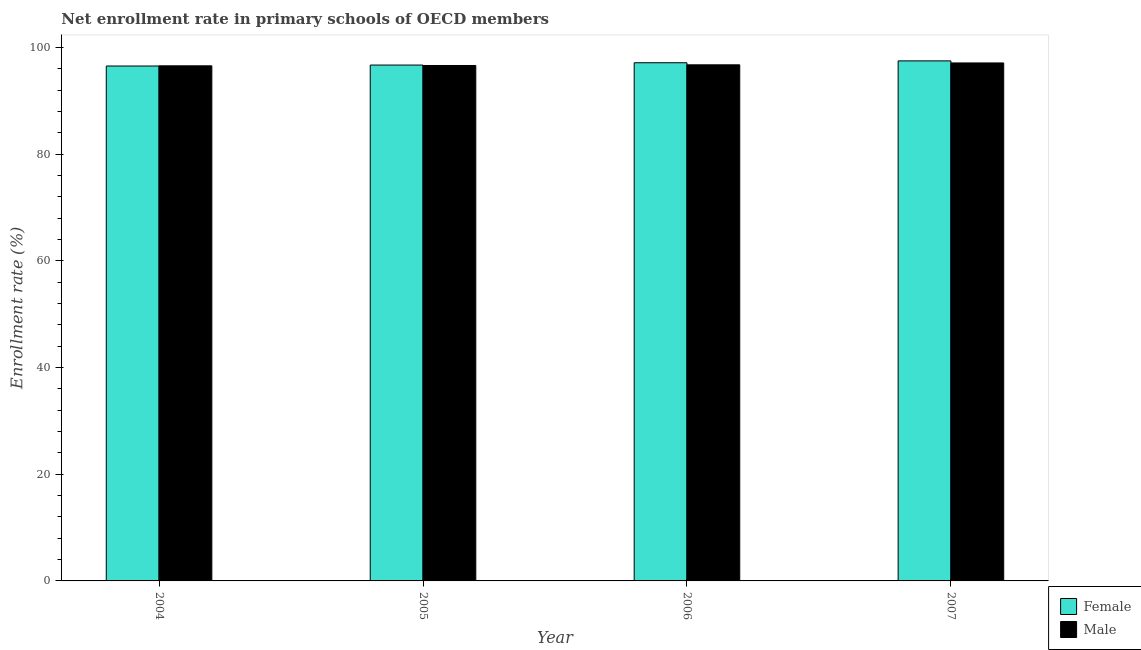How many groups of bars are there?
Ensure brevity in your answer.  4. What is the enrollment rate of male students in 2005?
Your answer should be very brief. 96.62. Across all years, what is the maximum enrollment rate of male students?
Offer a very short reply. 97.09. Across all years, what is the minimum enrollment rate of male students?
Your response must be concise. 96.55. What is the total enrollment rate of male students in the graph?
Your answer should be compact. 387. What is the difference between the enrollment rate of female students in 2006 and that in 2007?
Provide a succinct answer. -0.35. What is the difference between the enrollment rate of male students in 2007 and the enrollment rate of female students in 2004?
Your answer should be very brief. 0.54. What is the average enrollment rate of male students per year?
Provide a short and direct response. 96.75. What is the ratio of the enrollment rate of male students in 2005 to that in 2007?
Offer a terse response. 1. Is the enrollment rate of male students in 2005 less than that in 2006?
Provide a succinct answer. Yes. What is the difference between the highest and the second highest enrollment rate of female students?
Your answer should be very brief. 0.35. What is the difference between the highest and the lowest enrollment rate of female students?
Keep it short and to the point. 0.96. In how many years, is the enrollment rate of female students greater than the average enrollment rate of female students taken over all years?
Provide a short and direct response. 2. Is the sum of the enrollment rate of female students in 2004 and 2005 greater than the maximum enrollment rate of male students across all years?
Offer a terse response. Yes. What does the 2nd bar from the right in 2006 represents?
Offer a terse response. Female. How many bars are there?
Your response must be concise. 8. Are all the bars in the graph horizontal?
Your answer should be very brief. No. How many years are there in the graph?
Offer a terse response. 4. What is the difference between two consecutive major ticks on the Y-axis?
Your answer should be very brief. 20. Are the values on the major ticks of Y-axis written in scientific E-notation?
Offer a very short reply. No. How many legend labels are there?
Provide a succinct answer. 2. What is the title of the graph?
Your answer should be very brief. Net enrollment rate in primary schools of OECD members. What is the label or title of the Y-axis?
Provide a succinct answer. Enrollment rate (%). What is the Enrollment rate (%) of Female in 2004?
Offer a very short reply. 96.52. What is the Enrollment rate (%) in Male in 2004?
Provide a succinct answer. 96.55. What is the Enrollment rate (%) in Female in 2005?
Your response must be concise. 96.7. What is the Enrollment rate (%) in Male in 2005?
Provide a succinct answer. 96.62. What is the Enrollment rate (%) in Female in 2006?
Your answer should be compact. 97.13. What is the Enrollment rate (%) of Male in 2006?
Keep it short and to the point. 96.74. What is the Enrollment rate (%) of Female in 2007?
Give a very brief answer. 97.48. What is the Enrollment rate (%) in Male in 2007?
Your answer should be very brief. 97.09. Across all years, what is the maximum Enrollment rate (%) of Female?
Offer a terse response. 97.48. Across all years, what is the maximum Enrollment rate (%) of Male?
Provide a succinct answer. 97.09. Across all years, what is the minimum Enrollment rate (%) of Female?
Your answer should be very brief. 96.52. Across all years, what is the minimum Enrollment rate (%) in Male?
Your response must be concise. 96.55. What is the total Enrollment rate (%) of Female in the graph?
Offer a very short reply. 387.83. What is the total Enrollment rate (%) in Male in the graph?
Make the answer very short. 387. What is the difference between the Enrollment rate (%) in Female in 2004 and that in 2005?
Provide a succinct answer. -0.18. What is the difference between the Enrollment rate (%) of Male in 2004 and that in 2005?
Offer a terse response. -0.06. What is the difference between the Enrollment rate (%) of Female in 2004 and that in 2006?
Offer a terse response. -0.61. What is the difference between the Enrollment rate (%) in Male in 2004 and that in 2006?
Offer a terse response. -0.19. What is the difference between the Enrollment rate (%) of Female in 2004 and that in 2007?
Keep it short and to the point. -0.96. What is the difference between the Enrollment rate (%) in Male in 2004 and that in 2007?
Provide a succinct answer. -0.54. What is the difference between the Enrollment rate (%) in Female in 2005 and that in 2006?
Your answer should be very brief. -0.43. What is the difference between the Enrollment rate (%) in Male in 2005 and that in 2006?
Offer a very short reply. -0.13. What is the difference between the Enrollment rate (%) of Female in 2005 and that in 2007?
Make the answer very short. -0.78. What is the difference between the Enrollment rate (%) of Male in 2005 and that in 2007?
Offer a terse response. -0.48. What is the difference between the Enrollment rate (%) of Female in 2006 and that in 2007?
Provide a short and direct response. -0.35. What is the difference between the Enrollment rate (%) in Male in 2006 and that in 2007?
Provide a short and direct response. -0.35. What is the difference between the Enrollment rate (%) in Female in 2004 and the Enrollment rate (%) in Male in 2005?
Offer a terse response. -0.1. What is the difference between the Enrollment rate (%) of Female in 2004 and the Enrollment rate (%) of Male in 2006?
Offer a terse response. -0.22. What is the difference between the Enrollment rate (%) in Female in 2004 and the Enrollment rate (%) in Male in 2007?
Your response must be concise. -0.57. What is the difference between the Enrollment rate (%) in Female in 2005 and the Enrollment rate (%) in Male in 2006?
Ensure brevity in your answer.  -0.04. What is the difference between the Enrollment rate (%) of Female in 2005 and the Enrollment rate (%) of Male in 2007?
Provide a short and direct response. -0.4. What is the difference between the Enrollment rate (%) in Female in 2006 and the Enrollment rate (%) in Male in 2007?
Ensure brevity in your answer.  0.04. What is the average Enrollment rate (%) of Female per year?
Offer a very short reply. 96.96. What is the average Enrollment rate (%) in Male per year?
Provide a succinct answer. 96.75. In the year 2004, what is the difference between the Enrollment rate (%) of Female and Enrollment rate (%) of Male?
Make the answer very short. -0.04. In the year 2005, what is the difference between the Enrollment rate (%) in Female and Enrollment rate (%) in Male?
Make the answer very short. 0.08. In the year 2006, what is the difference between the Enrollment rate (%) in Female and Enrollment rate (%) in Male?
Your response must be concise. 0.39. In the year 2007, what is the difference between the Enrollment rate (%) in Female and Enrollment rate (%) in Male?
Provide a short and direct response. 0.39. What is the ratio of the Enrollment rate (%) of Female in 2004 to that in 2005?
Give a very brief answer. 1. What is the ratio of the Enrollment rate (%) in Male in 2004 to that in 2005?
Give a very brief answer. 1. What is the ratio of the Enrollment rate (%) in Male in 2004 to that in 2007?
Provide a succinct answer. 0.99. What is the ratio of the Enrollment rate (%) of Female in 2005 to that in 2006?
Ensure brevity in your answer.  1. What is the ratio of the Enrollment rate (%) of Male in 2005 to that in 2007?
Provide a short and direct response. 1. What is the difference between the highest and the second highest Enrollment rate (%) of Female?
Your answer should be very brief. 0.35. What is the difference between the highest and the second highest Enrollment rate (%) of Male?
Offer a terse response. 0.35. What is the difference between the highest and the lowest Enrollment rate (%) in Female?
Your answer should be compact. 0.96. What is the difference between the highest and the lowest Enrollment rate (%) in Male?
Provide a succinct answer. 0.54. 